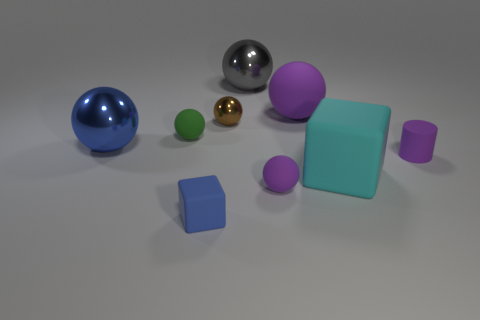Subtract all tiny rubber spheres. How many spheres are left? 4 Subtract all purple balls. How many balls are left? 4 Subtract all cyan spheres. Subtract all purple cylinders. How many spheres are left? 6 Subtract all green cylinders. How many gray balls are left? 1 Subtract all blocks. How many objects are left? 7 Subtract 1 blocks. How many blocks are left? 1 Subtract all purple matte balls. Subtract all small rubber objects. How many objects are left? 3 Add 8 purple cylinders. How many purple cylinders are left? 9 Add 9 large purple objects. How many large purple objects exist? 10 Add 1 tiny green rubber objects. How many objects exist? 10 